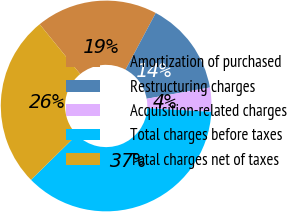<chart> <loc_0><loc_0><loc_500><loc_500><pie_chart><fcel>Amortization of purchased<fcel>Restructuring charges<fcel>Acquisition-related charges<fcel>Total charges before taxes<fcel>Total charges net of taxes<nl><fcel>18.67%<fcel>14.4%<fcel>3.69%<fcel>36.76%<fcel>26.49%<nl></chart> 